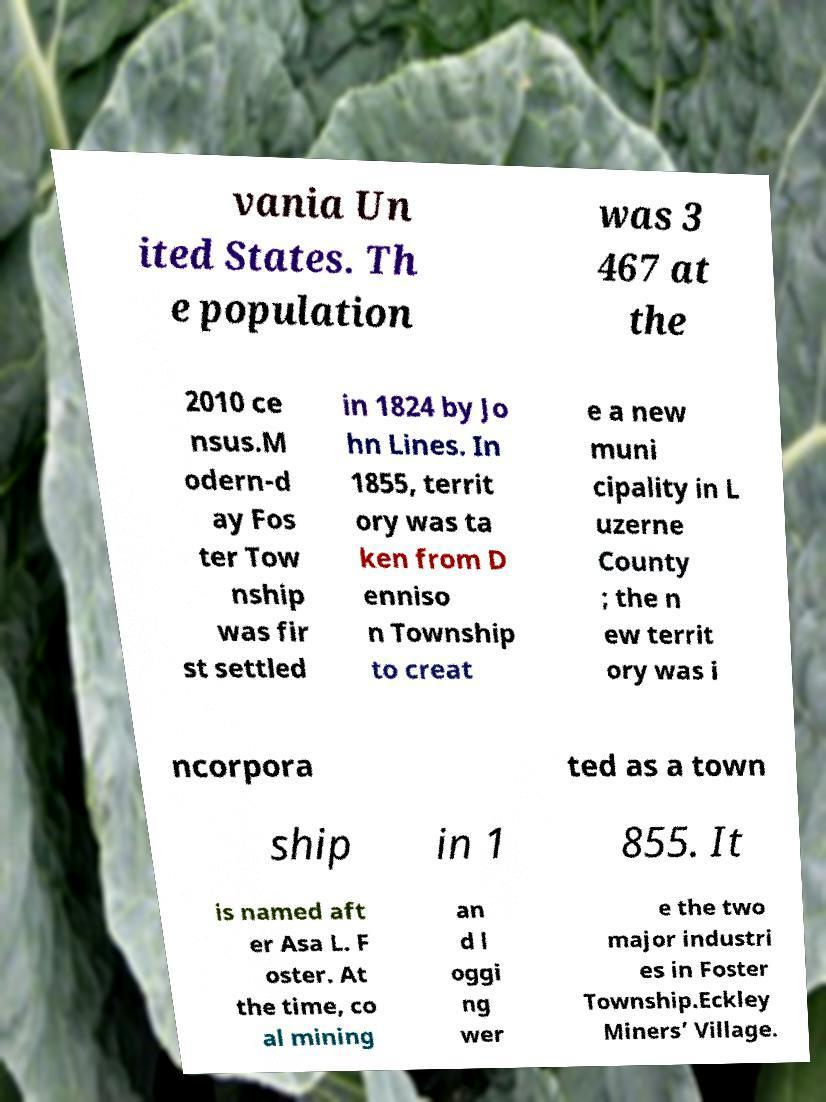Can you accurately transcribe the text from the provided image for me? vania Un ited States. Th e population was 3 467 at the 2010 ce nsus.M odern-d ay Fos ter Tow nship was fir st settled in 1824 by Jo hn Lines. In 1855, territ ory was ta ken from D enniso n Township to creat e a new muni cipality in L uzerne County ; the n ew territ ory was i ncorpora ted as a town ship in 1 855. It is named aft er Asa L. F oster. At the time, co al mining an d l oggi ng wer e the two major industri es in Foster Township.Eckley Miners’ Village. 